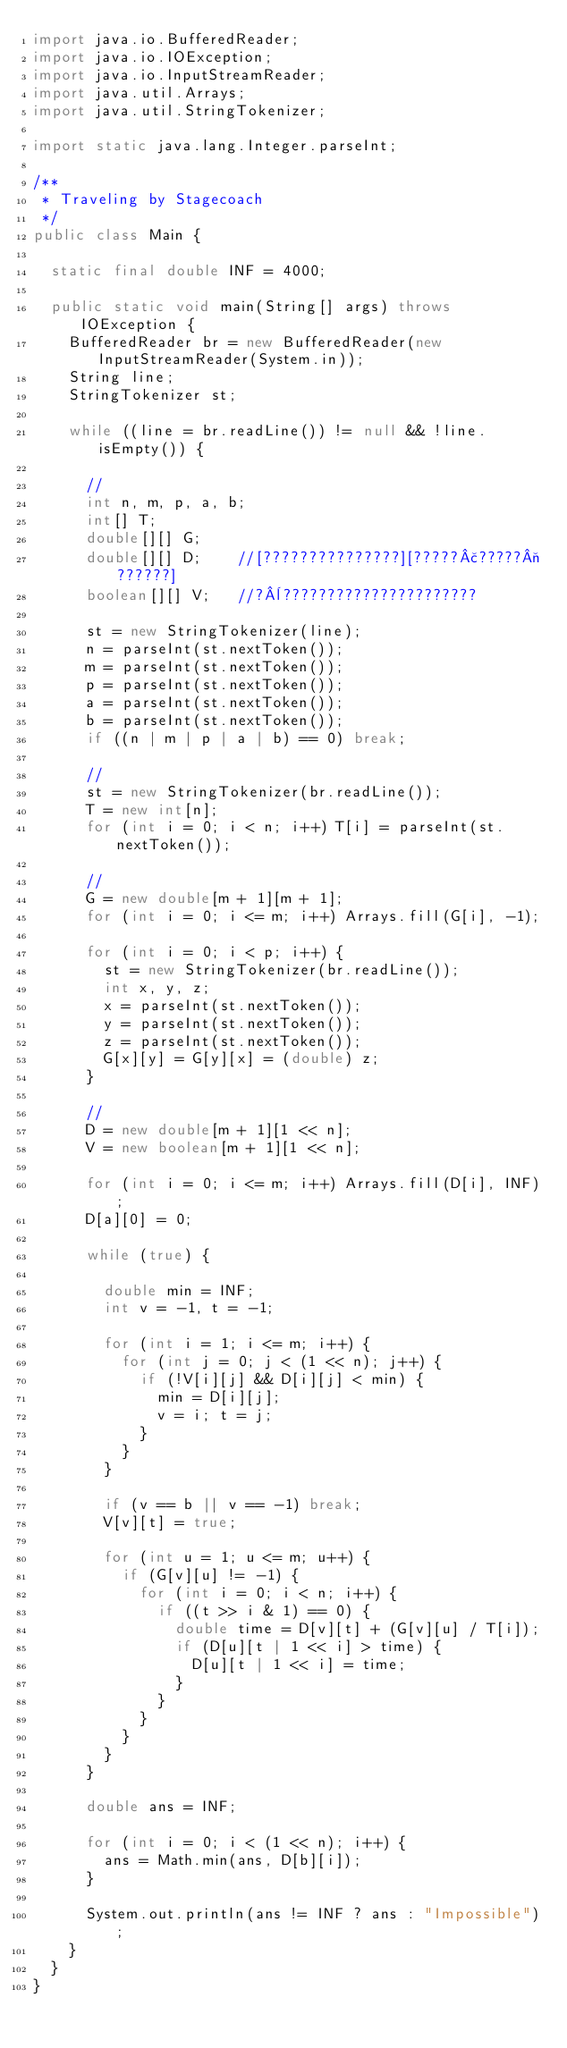Convert code to text. <code><loc_0><loc_0><loc_500><loc_500><_Java_>import java.io.BufferedReader;
import java.io.IOException;
import java.io.InputStreamReader;
import java.util.Arrays;
import java.util.StringTokenizer;

import static java.lang.Integer.parseInt;

/**
 * Traveling by Stagecoach
 */
public class Main {

	static final double INF = 4000;

	public static void main(String[] args) throws IOException {
		BufferedReader br = new BufferedReader(new InputStreamReader(System.in));
		String line;
		StringTokenizer st;

		while ((line = br.readLine()) != null && !line.isEmpty()) {

			//
			int n, m, p, a, b;
			int[] T;
			double[][] G;
			double[][] D;    //[???????????????][?????£?????¬??????]
			boolean[][] V;   //?¨??????????????????????

			st = new StringTokenizer(line);
			n = parseInt(st.nextToken());
			m = parseInt(st.nextToken());
			p = parseInt(st.nextToken());
			a = parseInt(st.nextToken());
			b = parseInt(st.nextToken());
			if ((n | m | p | a | b) == 0) break;

			//
			st = new StringTokenizer(br.readLine());
			T = new int[n];
			for (int i = 0; i < n; i++) T[i] = parseInt(st.nextToken());

			//
			G = new double[m + 1][m + 1];
			for (int i = 0; i <= m; i++) Arrays.fill(G[i], -1);

			for (int i = 0; i < p; i++) {
				st = new StringTokenizer(br.readLine());
				int x, y, z;
				x = parseInt(st.nextToken());
				y = parseInt(st.nextToken());
				z = parseInt(st.nextToken());
				G[x][y] = G[y][x] = (double) z;
			}

			//
			D = new double[m + 1][1 << n];
			V = new boolean[m + 1][1 << n];

			for (int i = 0; i <= m; i++) Arrays.fill(D[i], INF);
			D[a][0] = 0;

			while (true) {

				double min = INF;
				int v = -1, t = -1;

				for (int i = 1; i <= m; i++) {
					for (int j = 0; j < (1 << n); j++) {
						if (!V[i][j] && D[i][j] < min) {
							min = D[i][j];
							v = i; t = j;
						}
					}
				}

				if (v == b || v == -1) break;
				V[v][t] = true;

				for (int u = 1; u <= m; u++) {
					if (G[v][u] != -1) {
						for (int i = 0; i < n; i++) {
							if ((t >> i & 1) == 0) {
								double time = D[v][t] + (G[v][u] / T[i]);
								if (D[u][t | 1 << i] > time) {
									D[u][t | 1 << i] = time;
								}
							}
						}
					}
				}
			}

			double ans = INF;

			for (int i = 0; i < (1 << n); i++) {
				ans = Math.min(ans, D[b][i]);
			}

			System.out.println(ans != INF ? ans : "Impossible");
		}
	}
}</code> 